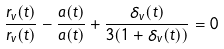Convert formula to latex. <formula><loc_0><loc_0><loc_500><loc_500>\frac { \dot { r } _ { v } ( t ) } { r _ { v } ( t ) } - \frac { \dot { a } ( t ) } { a ( t ) } + \frac { \dot { \delta } _ { v } ( t ) } { 3 ( 1 + \delta _ { v } ( t ) ) } = 0</formula> 